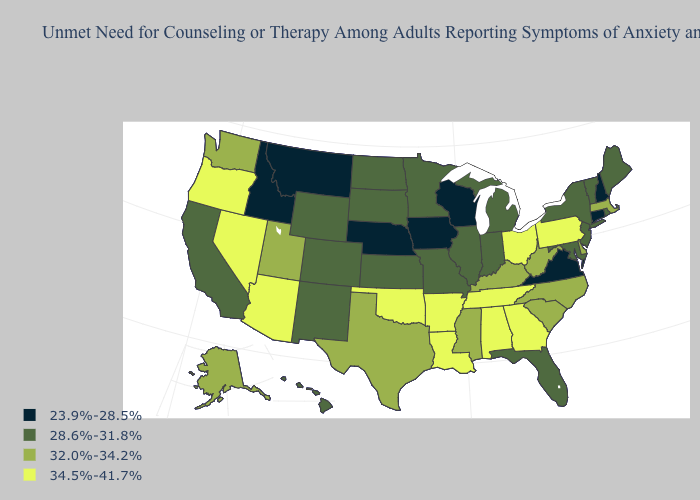Name the states that have a value in the range 28.6%-31.8%?
Give a very brief answer. California, Colorado, Florida, Hawaii, Illinois, Indiana, Kansas, Maine, Maryland, Michigan, Minnesota, Missouri, New Jersey, New Mexico, New York, North Dakota, Rhode Island, South Dakota, Vermont, Wyoming. What is the lowest value in the West?
Write a very short answer. 23.9%-28.5%. What is the highest value in states that border Iowa?
Quick response, please. 28.6%-31.8%. Does the map have missing data?
Answer briefly. No. What is the value of Michigan?
Keep it brief. 28.6%-31.8%. How many symbols are there in the legend?
Quick response, please. 4. Among the states that border Wisconsin , which have the highest value?
Quick response, please. Illinois, Michigan, Minnesota. Does Florida have the highest value in the South?
Quick response, please. No. What is the value of Wyoming?
Be succinct. 28.6%-31.8%. What is the lowest value in the Northeast?
Give a very brief answer. 23.9%-28.5%. What is the value of Maryland?
Short answer required. 28.6%-31.8%. Does Missouri have the lowest value in the USA?
Quick response, please. No. Name the states that have a value in the range 28.6%-31.8%?
Give a very brief answer. California, Colorado, Florida, Hawaii, Illinois, Indiana, Kansas, Maine, Maryland, Michigan, Minnesota, Missouri, New Jersey, New Mexico, New York, North Dakota, Rhode Island, South Dakota, Vermont, Wyoming. Does Oregon have a higher value than Louisiana?
Quick response, please. No. Does Alaska have the lowest value in the West?
Give a very brief answer. No. 